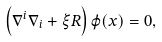<formula> <loc_0><loc_0><loc_500><loc_500>\left ( \nabla ^ { i } \nabla _ { i } + \xi R \right ) \varphi ( x ) = 0 ,</formula> 